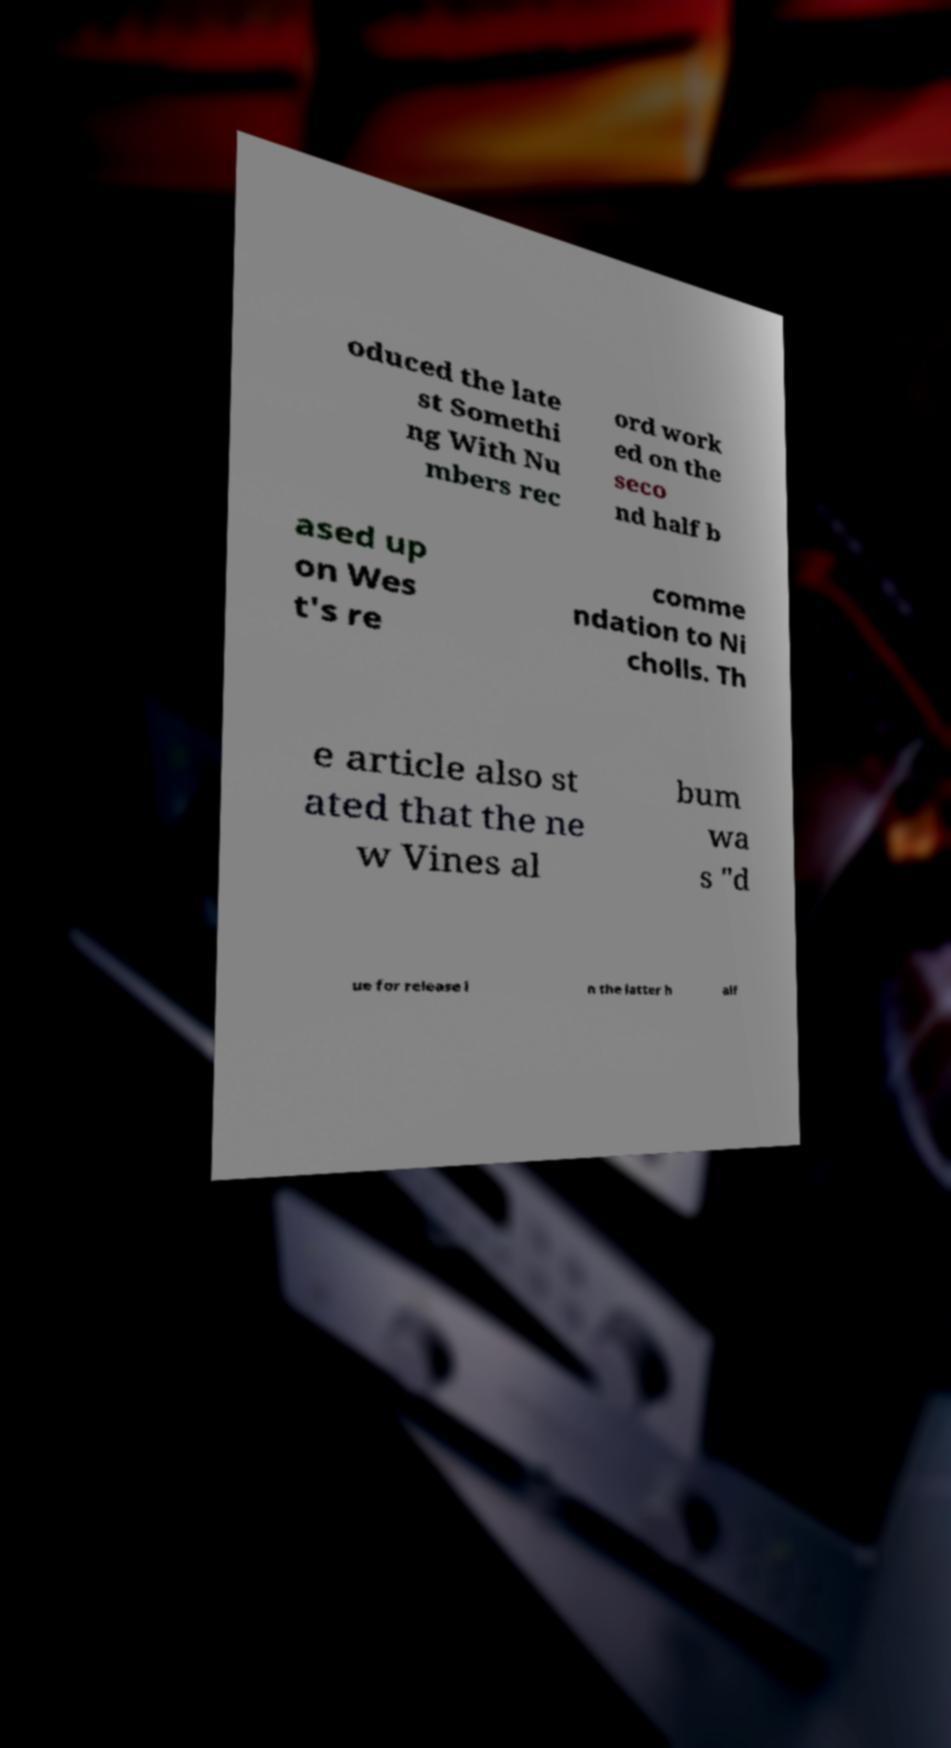Can you read and provide the text displayed in the image?This photo seems to have some interesting text. Can you extract and type it out for me? oduced the late st Somethi ng With Nu mbers rec ord work ed on the seco nd half b ased up on Wes t's re comme ndation to Ni cholls. Th e article also st ated that the ne w Vines al bum wa s "d ue for release i n the latter h alf 